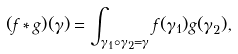Convert formula to latex. <formula><loc_0><loc_0><loc_500><loc_500>( f * g ) ( \gamma ) = \int _ { \gamma _ { 1 } \circ \gamma _ { 2 } = \gamma } f ( \gamma _ { 1 } ) g ( \gamma _ { 2 } ) ,</formula> 